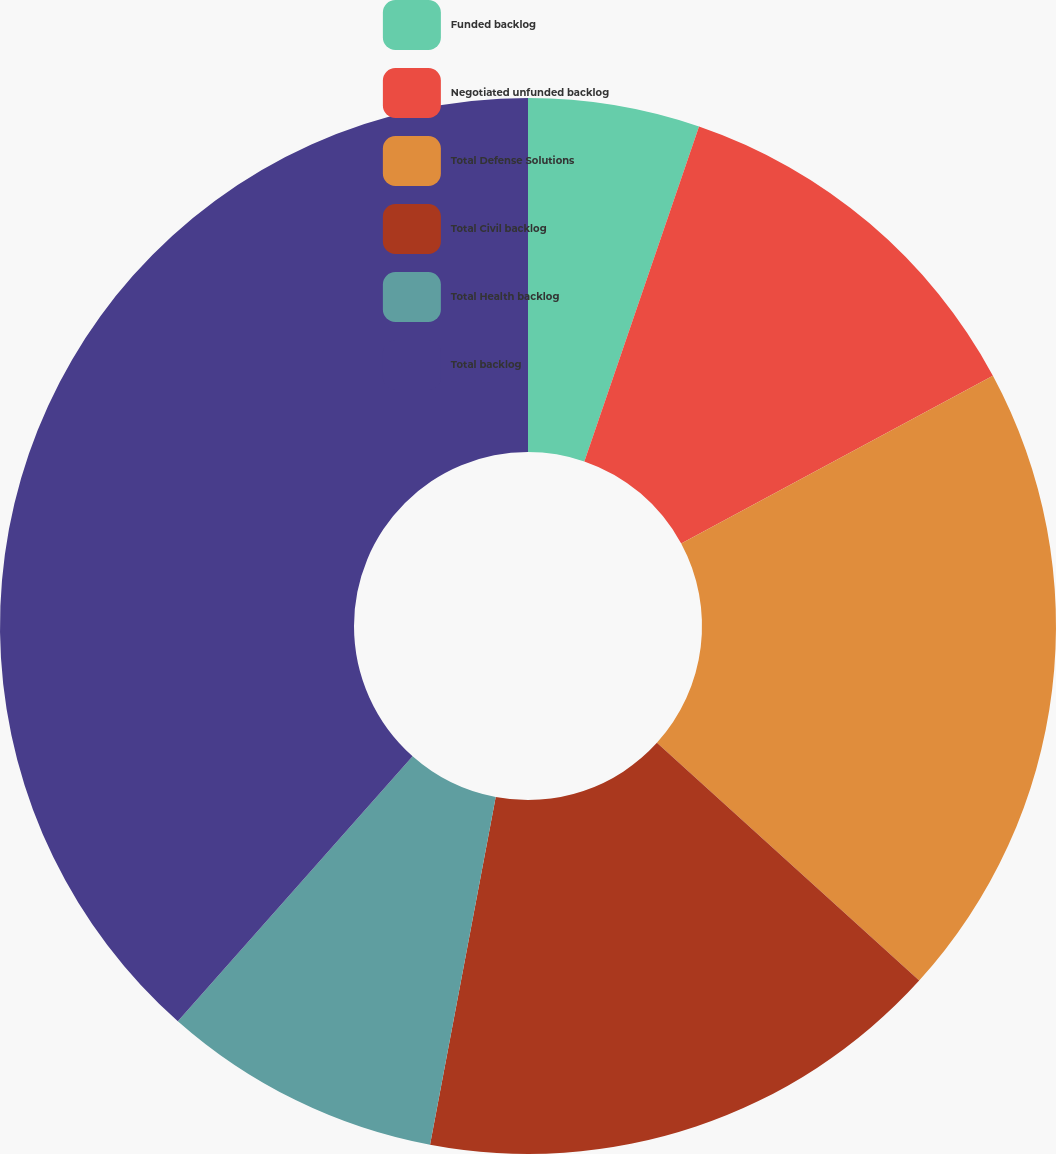Convert chart. <chart><loc_0><loc_0><loc_500><loc_500><pie_chart><fcel>Funded backlog<fcel>Negotiated unfunded backlog<fcel>Total Defense Solutions<fcel>Total Civil backlog<fcel>Total Health backlog<fcel>Total backlog<nl><fcel>5.25%<fcel>11.89%<fcel>19.58%<fcel>16.25%<fcel>8.57%<fcel>38.46%<nl></chart> 